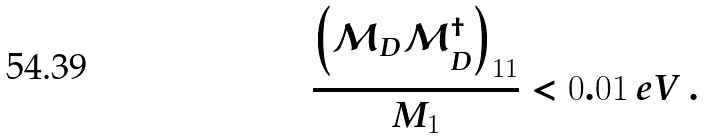Convert formula to latex. <formula><loc_0><loc_0><loc_500><loc_500>\frac { \left ( \mathcal { M } _ { D } \mathcal { M } _ { D } ^ { \dagger } \right ) _ { 1 1 } } { M _ { 1 } } < 0 . 0 1 \, e V \, .</formula> 